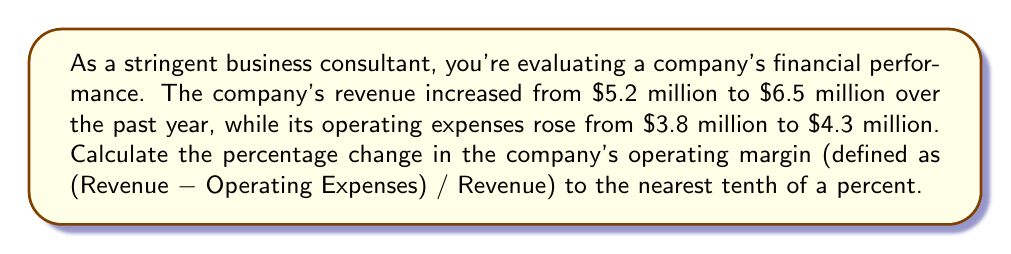Provide a solution to this math problem. To solve this problem, we'll follow these steps:

1. Calculate the initial operating margin:
   Initial Revenue = $5.2 million
   Initial Operating Expenses = $3.8 million
   Initial Operating Margin = $\frac{5.2 - 3.8}{5.2} = \frac{1.4}{5.2} = 0.2692$ or 26.92%

2. Calculate the final operating margin:
   Final Revenue = $6.5 million
   Final Operating Expenses = $4.3 million
   Final Operating Margin = $\frac{6.5 - 4.3}{6.5} = \frac{2.2}{6.5} = 0.3385$ or 33.85%

3. Calculate the percentage change in operating margin:
   Percentage Change = $\frac{\text{New Value} - \text{Original Value}}{\text{Original Value}} \times 100\%$
   
   $= \frac{0.3385 - 0.2692}{0.2692} \times 100\%$
   
   $= \frac{0.0693}{0.2692} \times 100\%$
   
   $= 0.2574 \times 100\%$
   
   $= 25.74\%$

4. Round to the nearest tenth of a percent:
   25.7%
Answer: The percentage change in the company's operating margin is 25.7%. 